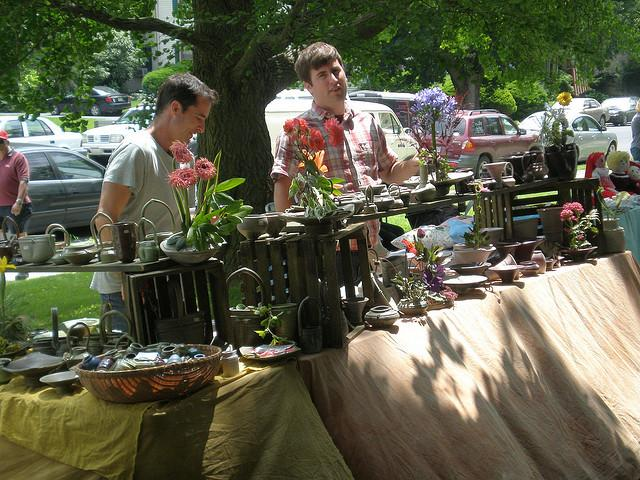What items are being shown off most frequently here? Please explain your reasoning. pottery. Pottery is being shown. 